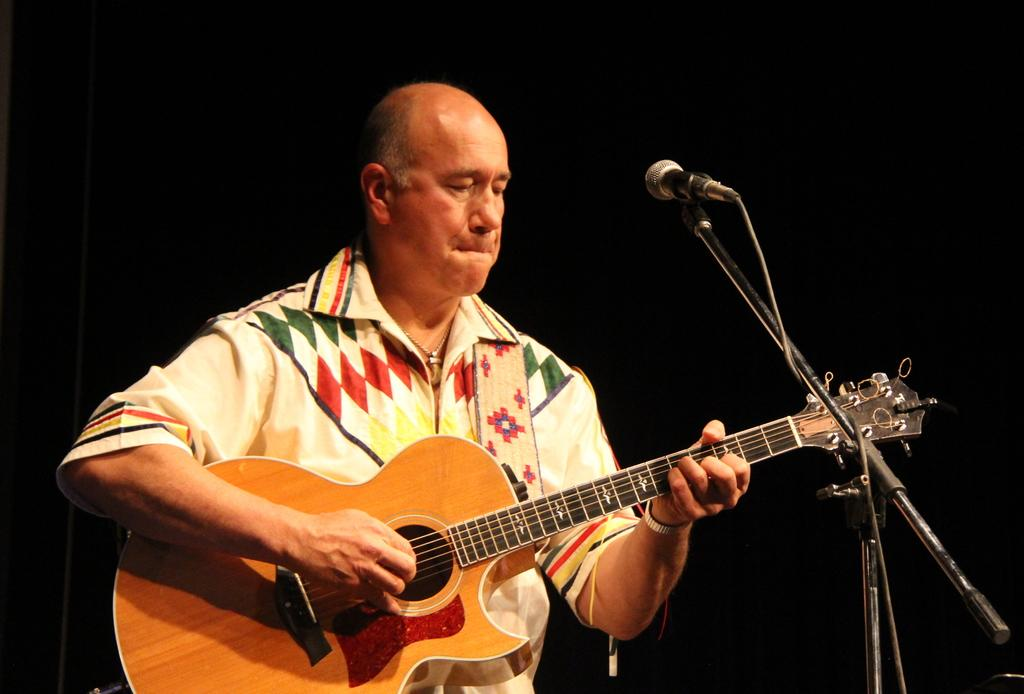What is the man in the image doing? The man is playing a guitar in the image. What is the man wearing in the image? The man is wearing a cream shirt in the image. Can you describe any accessories the man is wearing? Yes, there is a watch on the man's left hand in the image. What other object can be seen in the image related to the man's activity? There is a microphone in the image. What type of jelly is the man eating in the image? There is no jelly present in the image; the man is playing a guitar and wearing a cream shirt. 